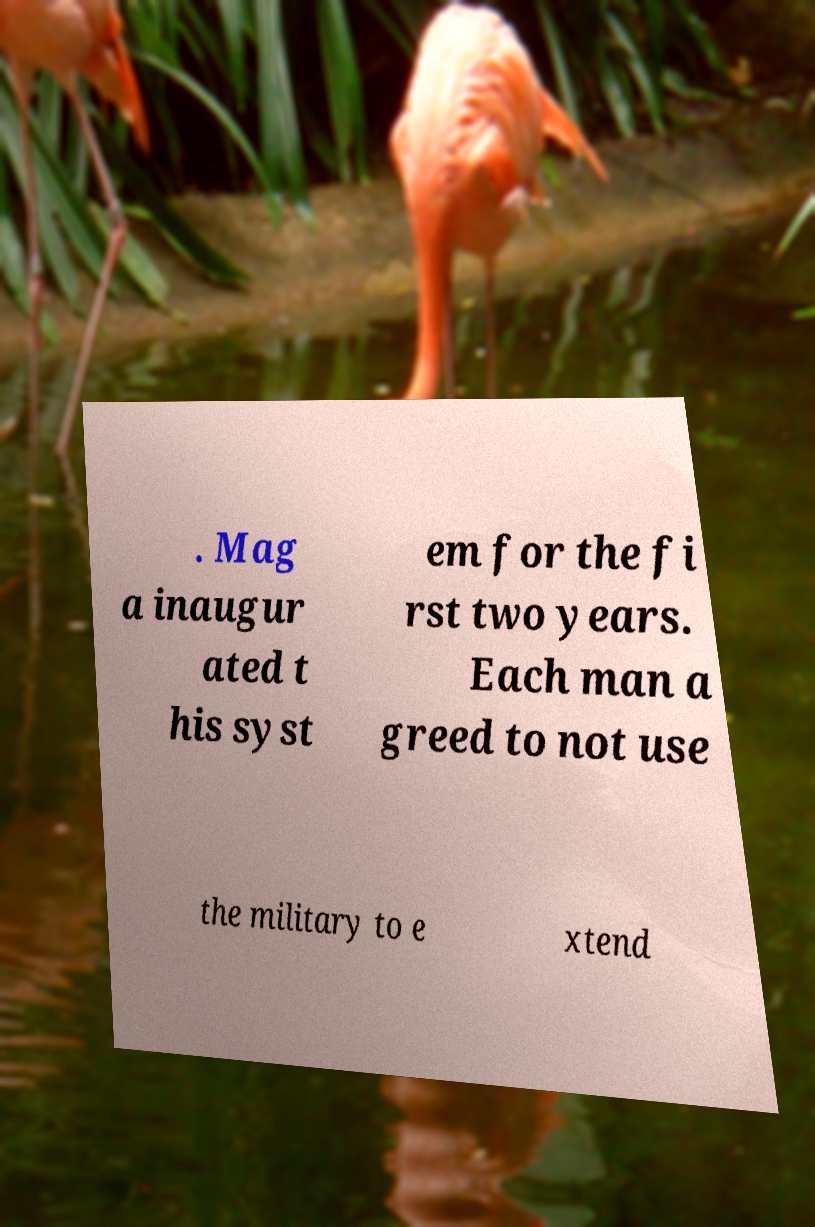What messages or text are displayed in this image? I need them in a readable, typed format. . Mag a inaugur ated t his syst em for the fi rst two years. Each man a greed to not use the military to e xtend 